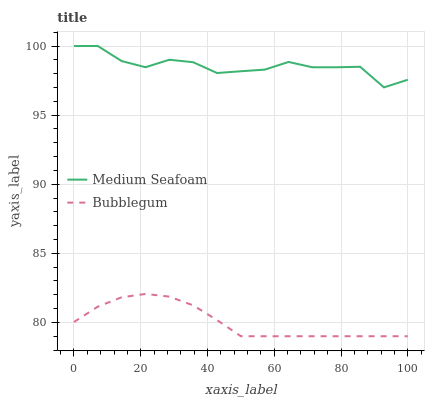Does Bubblegum have the minimum area under the curve?
Answer yes or no. Yes. Does Medium Seafoam have the maximum area under the curve?
Answer yes or no. Yes. Does Bubblegum have the maximum area under the curve?
Answer yes or no. No. Is Bubblegum the smoothest?
Answer yes or no. Yes. Is Medium Seafoam the roughest?
Answer yes or no. Yes. Is Bubblegum the roughest?
Answer yes or no. No. Does Bubblegum have the lowest value?
Answer yes or no. Yes. Does Medium Seafoam have the highest value?
Answer yes or no. Yes. Does Bubblegum have the highest value?
Answer yes or no. No. Is Bubblegum less than Medium Seafoam?
Answer yes or no. Yes. Is Medium Seafoam greater than Bubblegum?
Answer yes or no. Yes. Does Bubblegum intersect Medium Seafoam?
Answer yes or no. No. 